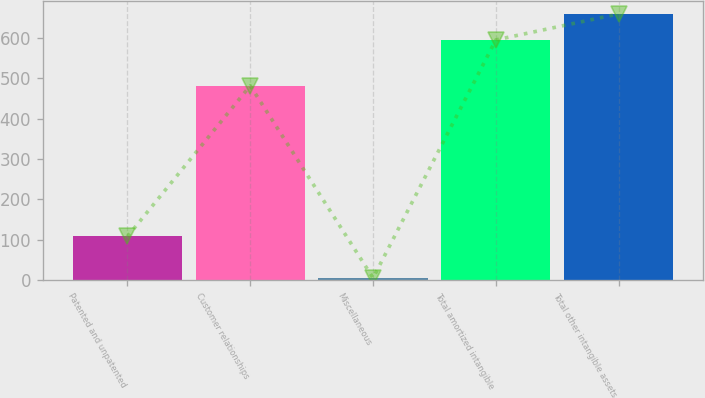<chart> <loc_0><loc_0><loc_500><loc_500><bar_chart><fcel>Patented and unpatented<fcel>Customer relationships<fcel>Miscellaneous<fcel>Total amortized intangible<fcel>Total other intangible assets<nl><fcel>108.1<fcel>481.4<fcel>5.3<fcel>594.8<fcel>659.23<nl></chart> 